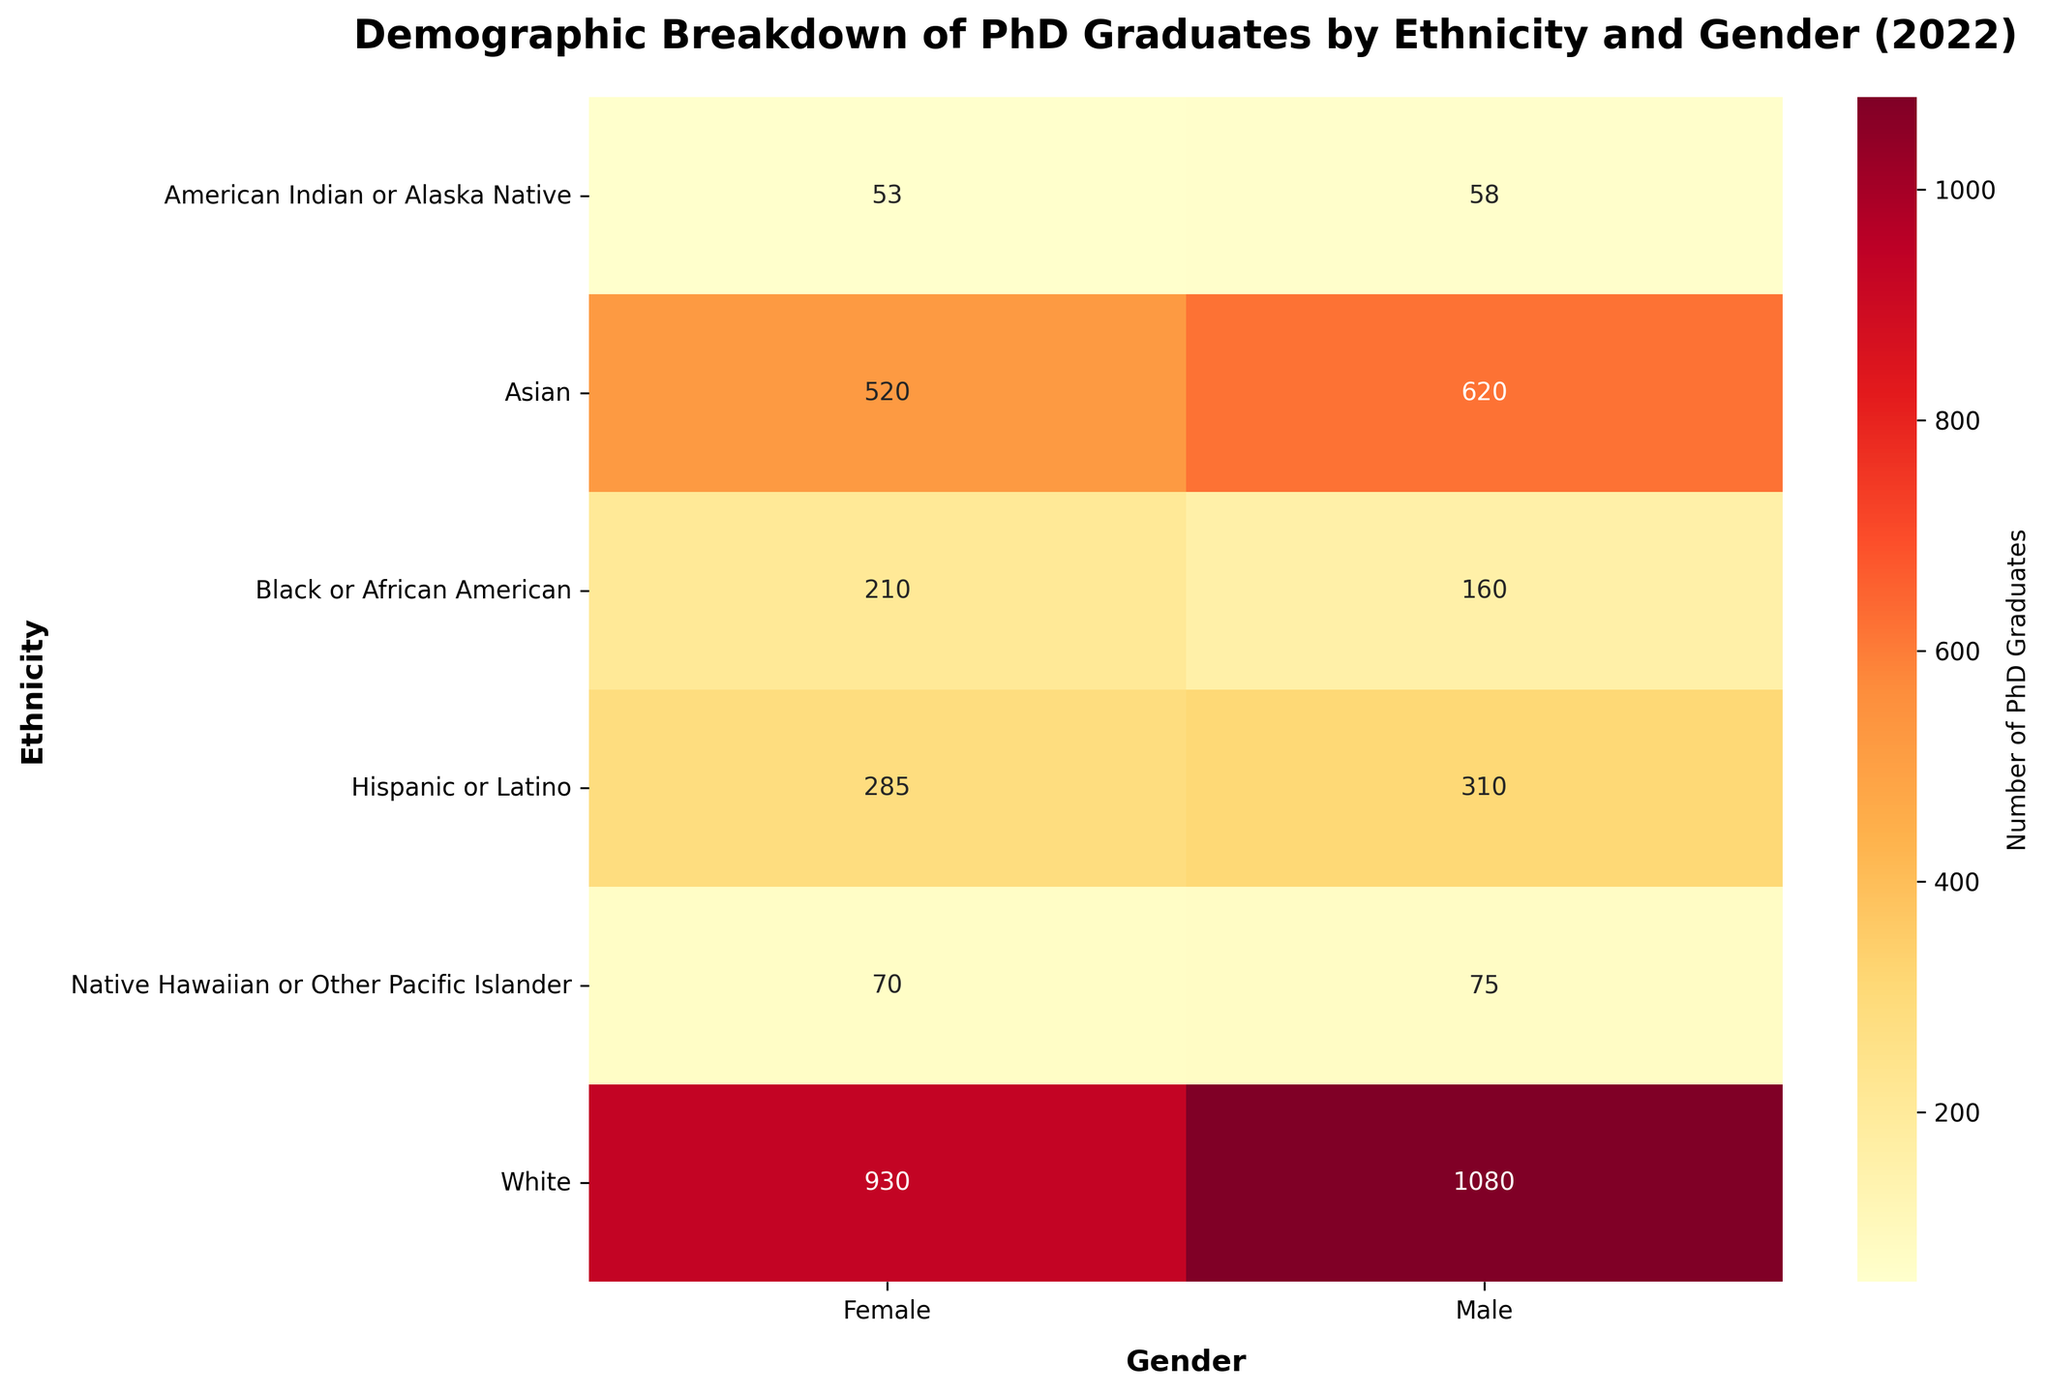What is the title of the heatmap figure? The title is located at the top of the heatmap and provides a summary of the visualized data. In this case, the title is "Demographic Breakdown of PhD Graduates by Ethnicity and Gender (2022)".
Answer: Demographic Breakdown of PhD Graduates by Ethnicity and Gender (2022) Which Ethnicity with Male gender has the highest number of PhD graduates in 2022? Look at the heatmap under the Male column. Compare the numbers for all ethnicities. The highest number for males is 1080 for White.
Answer: White What is the total number of PhD graduates for Asian ethnicity in 2022 combining both genders? Sum the numbers under the Asian row for both Male and Female columns. This is 620 (Male) + 520 (Female).
Answer: 1140 Which gender has more PhD graduates among Black or African American ethnicity in 2022? Compare the numbers in the Black or African American row under the Male and Female columns. Female graduates are 210, while Male graduates are 160.
Answer: Female What is the difference in the number of PhD graduates between Hispanic or Latino Male and Hispanic or Latino Female in 2022? Subtract the number of Female graduates from the number of Male graduates for Hispanic or Latino ethnicity. This is 310 (Male) - 285 (Female).
Answer: 25 Which gender shows a greater number of PhD graduates overall, Male or Female? Sum all the values in the Male column and compare with the sum of all values in the Female column. Calculate the totals: Males (1080 + 620 + 160 + 200 + 310 + 75 + 58) and Females (930 + 520 + 210 + 285 + 300 + 70 + 53). Compare the totals.
Answer: Male Among all ethnicities listed, which gender has the least number of PhD graduates in 2022, and what is that number? Compare all numbers across both Male and Female columns to find the smallest value. The smallest value is 53 for American Indian or Alaska Native Female.
Answer: Female, 53 How many more PhD graduates are there from the Asian Male group compared to the Native Hawaiian or Other Pacific Islander Male group in 2022? Subtract the number of Native Hawaiian or Other Pacific Islander Male graduates from the number of Asian Male graduates. This is 620 (Asian) - 75 (Native Hawaiian or Other Pacific Islander).
Answer: 545 What is the average number of PhD graduates for the White ethnicity across both genders in 2022? Calculate the sum of Male and Female graduates for White ethnicity and then divide by 2. This is (1080 + 930) / 2.
Answer: 1005 Which gender and ethnicity combination has the second highest number of PhD graduates in 2022? Exclude the highest number (1080 for White Male) and find the next highest number. The second highest is 620 for Asian Male.
Answer: Asian Male 